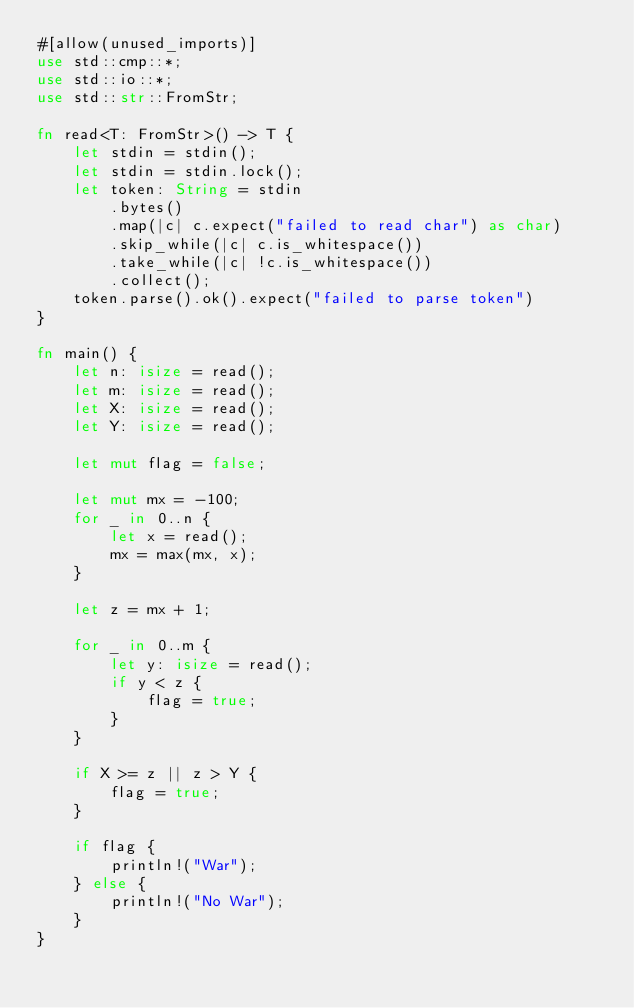Convert code to text. <code><loc_0><loc_0><loc_500><loc_500><_Rust_>#[allow(unused_imports)]
use std::cmp::*;
use std::io::*;
use std::str::FromStr;

fn read<T: FromStr>() -> T {
    let stdin = stdin();
    let stdin = stdin.lock();
    let token: String = stdin
        .bytes()
        .map(|c| c.expect("failed to read char") as char)
        .skip_while(|c| c.is_whitespace())
        .take_while(|c| !c.is_whitespace())
        .collect();
    token.parse().ok().expect("failed to parse token")
}

fn main() {
    let n: isize = read();
    let m: isize = read();
    let X: isize = read();
    let Y: isize = read();

    let mut flag = false;

    let mut mx = -100;
    for _ in 0..n {
        let x = read();
        mx = max(mx, x);
    }

    let z = mx + 1;

    for _ in 0..m {
        let y: isize = read();
        if y < z {
            flag = true;
        }
    }

    if X >= z || z > Y {
        flag = true;
    }

    if flag {
        println!("War");
    } else {
        println!("No War");
    }
}</code> 